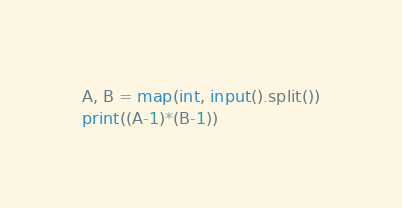<code> <loc_0><loc_0><loc_500><loc_500><_Python_>A, B = map(int, input().split())
print((A-1)*(B-1))</code> 